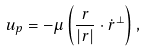<formula> <loc_0><loc_0><loc_500><loc_500>u _ { p } = - \mu \left ( \frac { r } { | { r } | } \cdot \dot { r } ^ { \perp } \right ) ,</formula> 